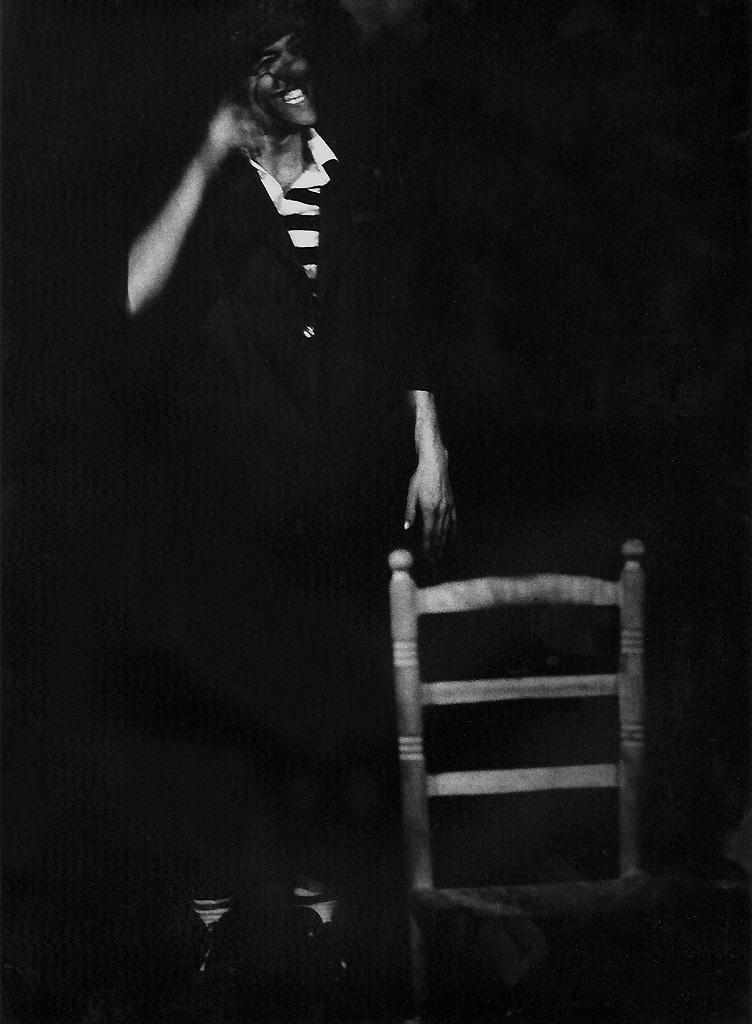What is the color scheme of the image? The image is black and white. Can you describe the main subject in the image? There is a person in the image. What object is present in the image besides the person? There is a chair in the image. What type of marble is being used as a table in the image? There is no table or marble present in the image; it only features a person and a chair. What color are the person's lips in the image? The image is black and white, so it is not possible to determine the color of the person's lips. 